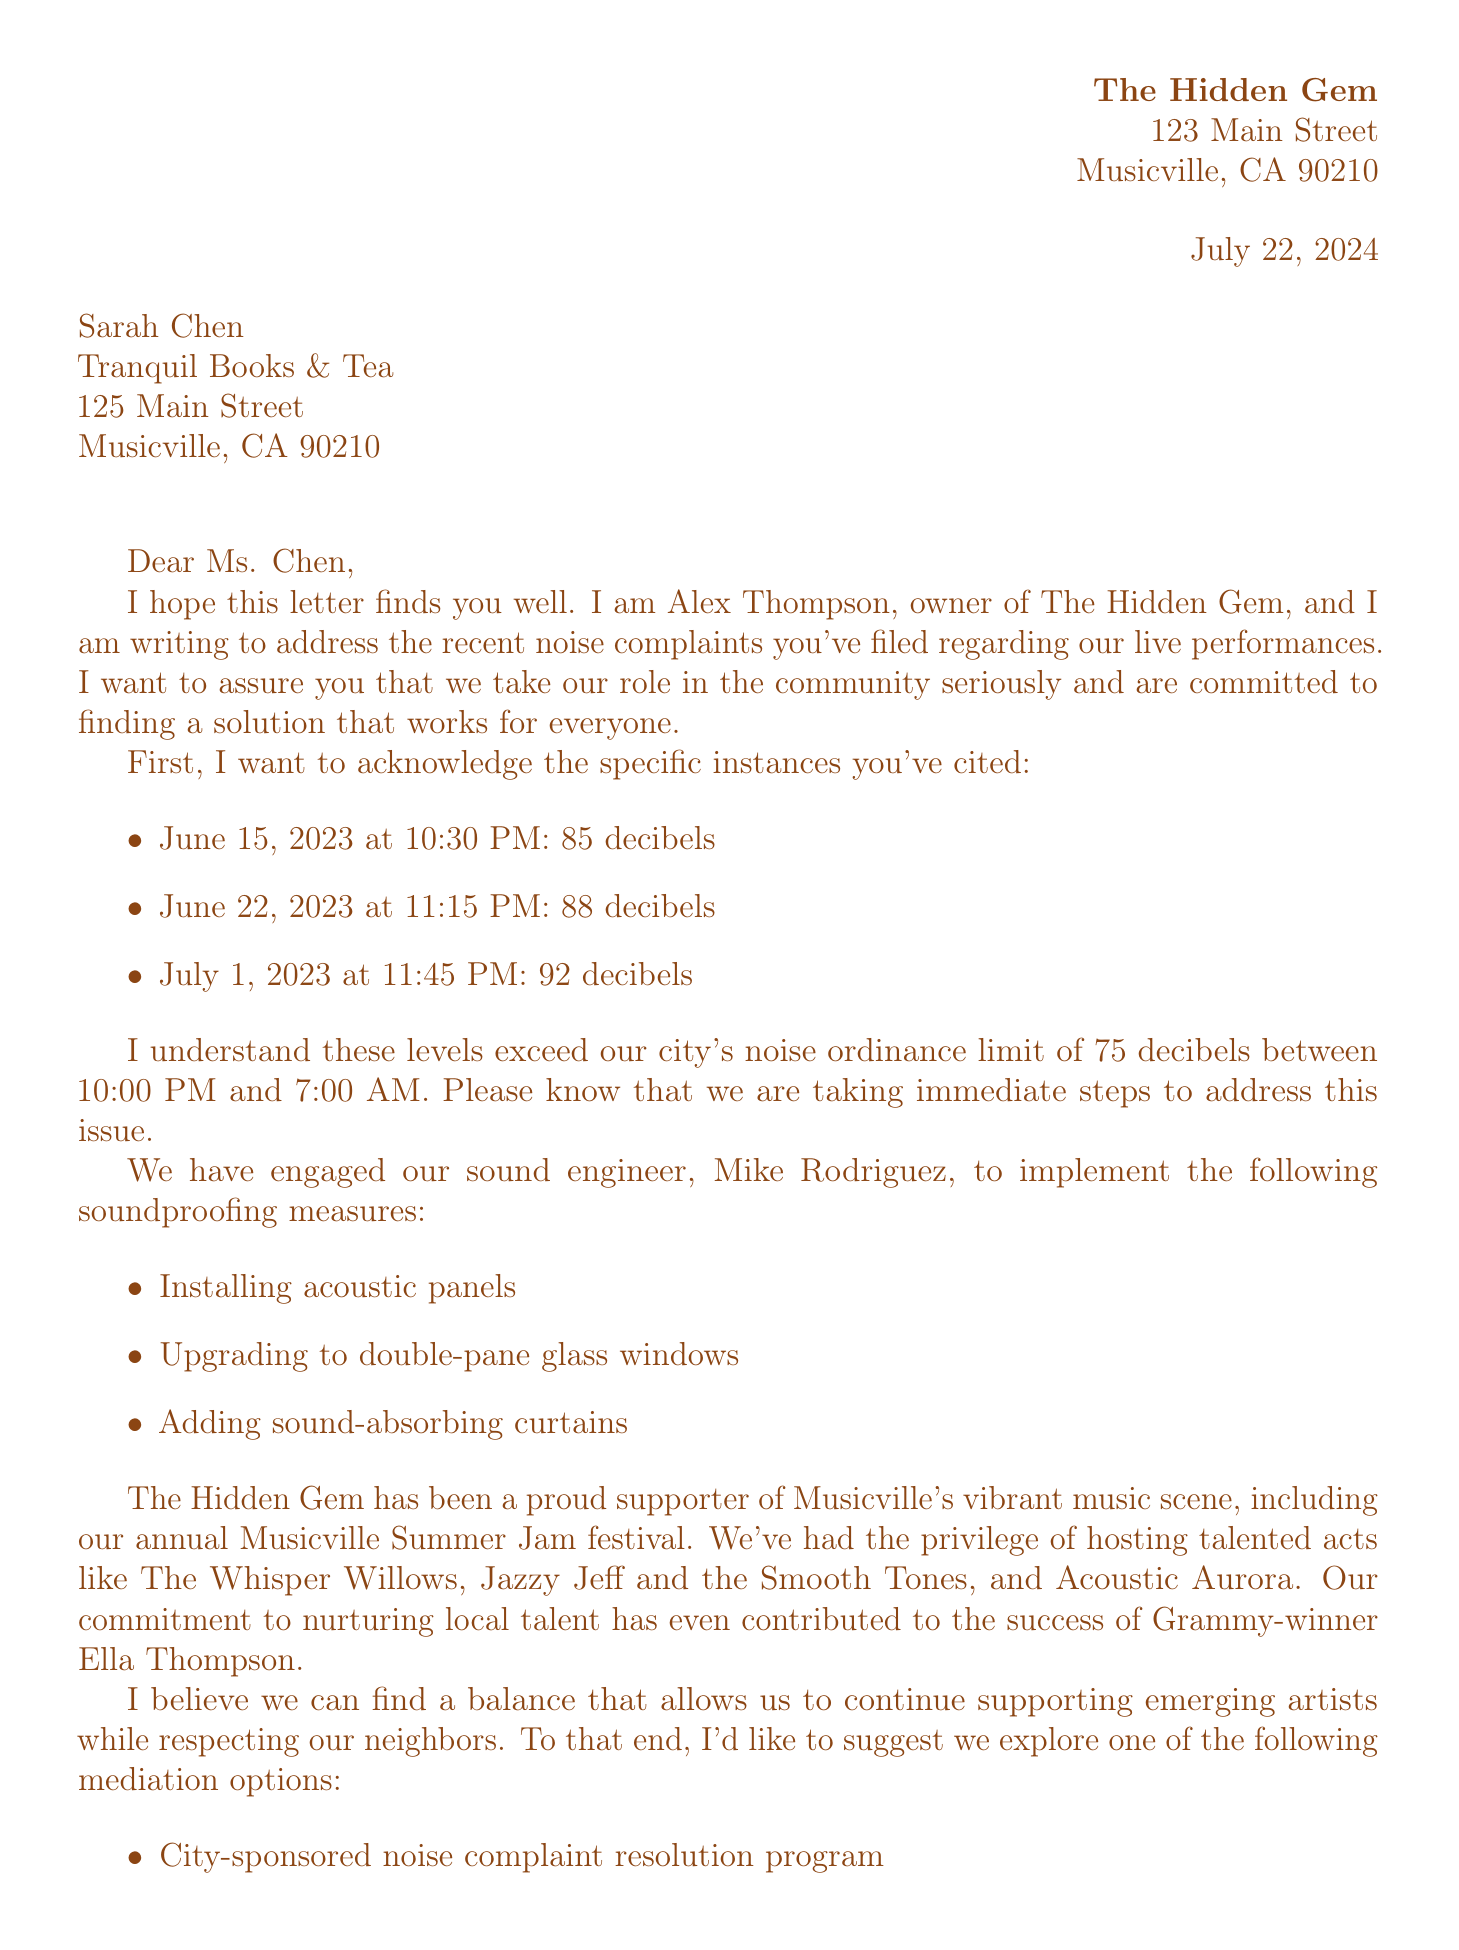What is the name of the bar owner? The letter indicates that the bar owner is Alex Thompson.
Answer: Alex Thompson What is the address of Tranquil Books & Tea? The letter provides the address as 125 Main Street, Musicville, CA 90210.
Answer: 125 Main Street, Musicville, CA 90210 What was the decibel level on July 1, 2023? The document states the decibel level on this date was 92.
Answer: 92 What time restriction is mentioned in the city noise ordinance? The ordinance specifies a time restriction from 10:00 PM to 7:00 AM.
Answer: 10:00 PM to 7:00 AM How many signature petitioners supported The Hidden Gem? The letter mentions there are 500 petition signers.
Answer: 500 What is the name of the sound engineer? The document states the sound engineer's name is Mike Rodriguez.
Answer: Mike Rodriguez Which mediation option involves the city? The letter mentions a city-sponsored noise complaint resolution program as a mediation option.
Answer: City-sponsored noise complaint resolution program What are the names of two bands that performed at The Hidden Gem? The letter lists two bands: The Whisper Willows and Jazzy Jeff and the Smooth Tones.
Answer: The Whisper Willows, Jazzy Jeff and the Smooth Tones What soundproofing measure involves windows? The letter states they will upgrade to double-pane glass windows as a soundproofing measure.
Answer: Upgrade to double-pane glass windows 